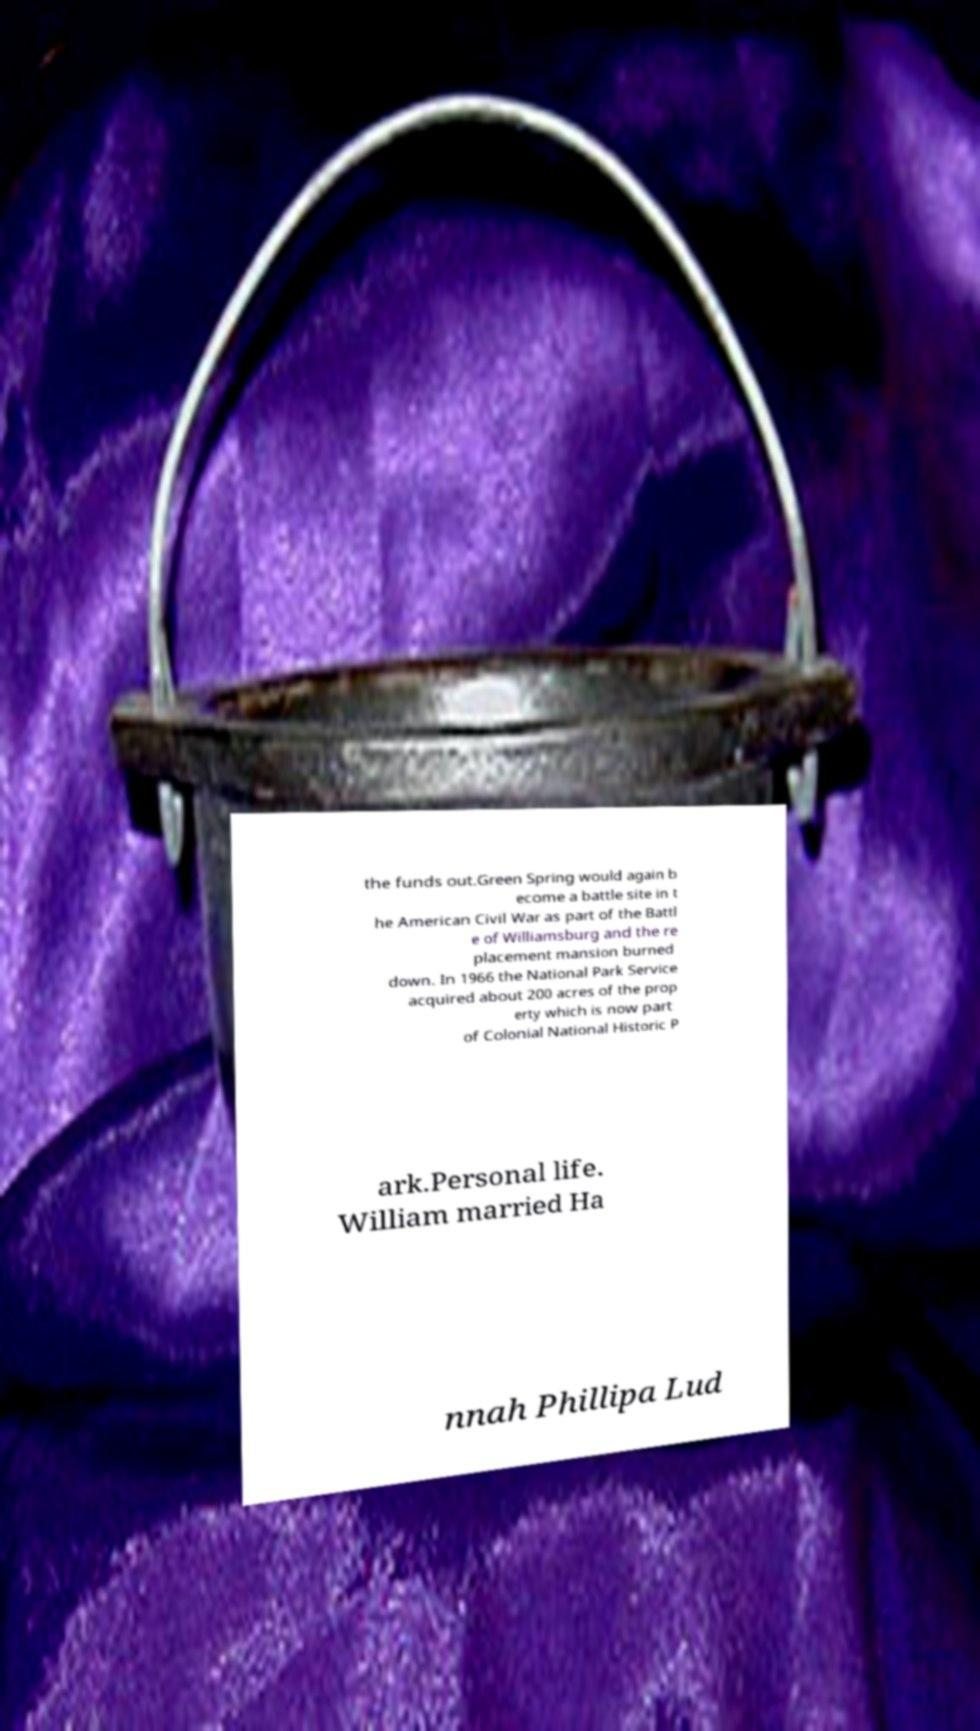Could you assist in decoding the text presented in this image and type it out clearly? the funds out.Green Spring would again b ecome a battle site in t he American Civil War as part of the Battl e of Williamsburg and the re placement mansion burned down. In 1966 the National Park Service acquired about 200 acres of the prop erty which is now part of Colonial National Historic P ark.Personal life. William married Ha nnah Phillipa Lud 